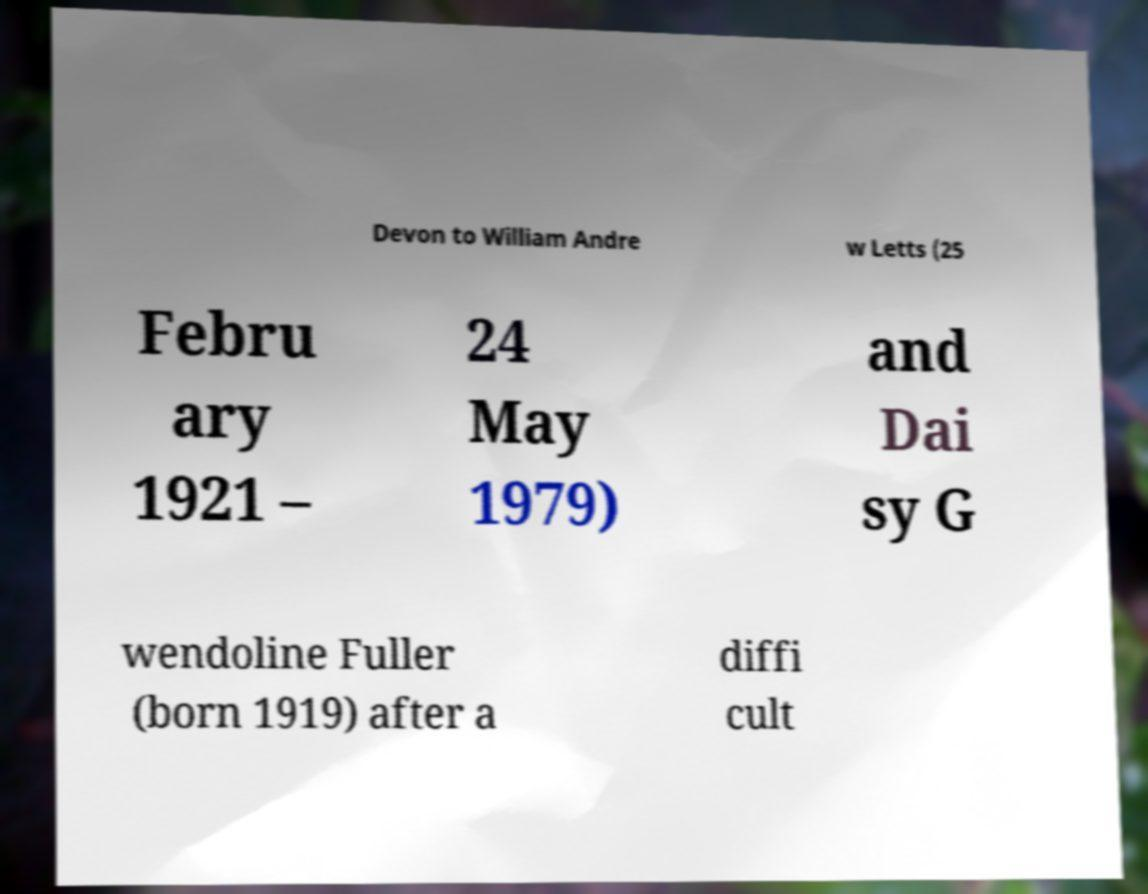I need the written content from this picture converted into text. Can you do that? Devon to William Andre w Letts (25 Febru ary 1921 – 24 May 1979) and Dai sy G wendoline Fuller (born 1919) after a diffi cult 